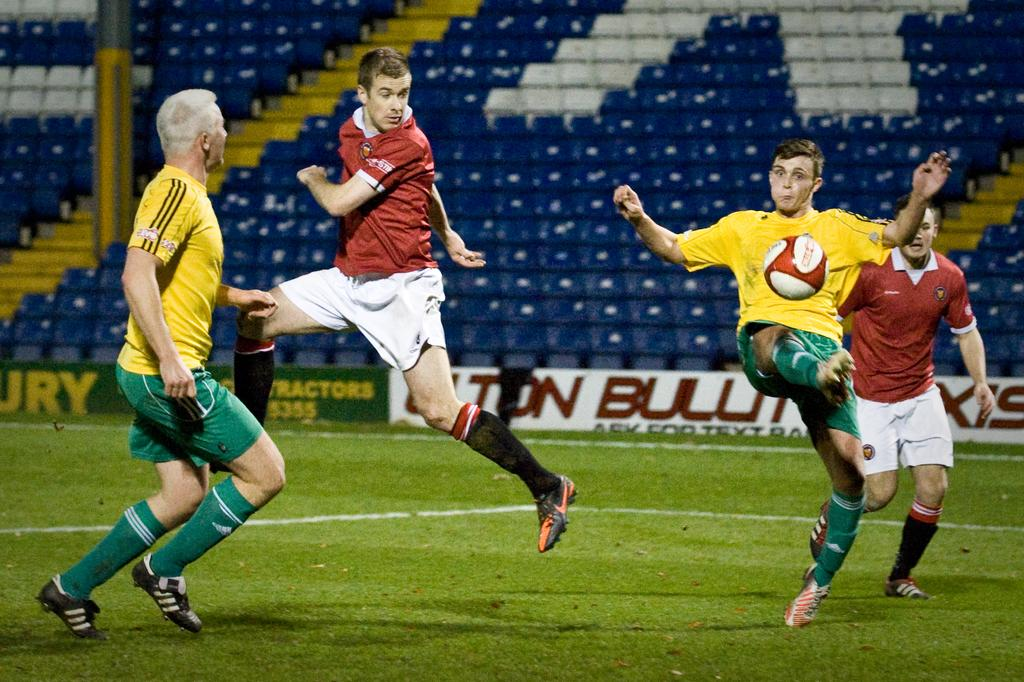<image>
Create a compact narrative representing the image presented. Soccer players in front of a green banner with the letters URY in yellow. 